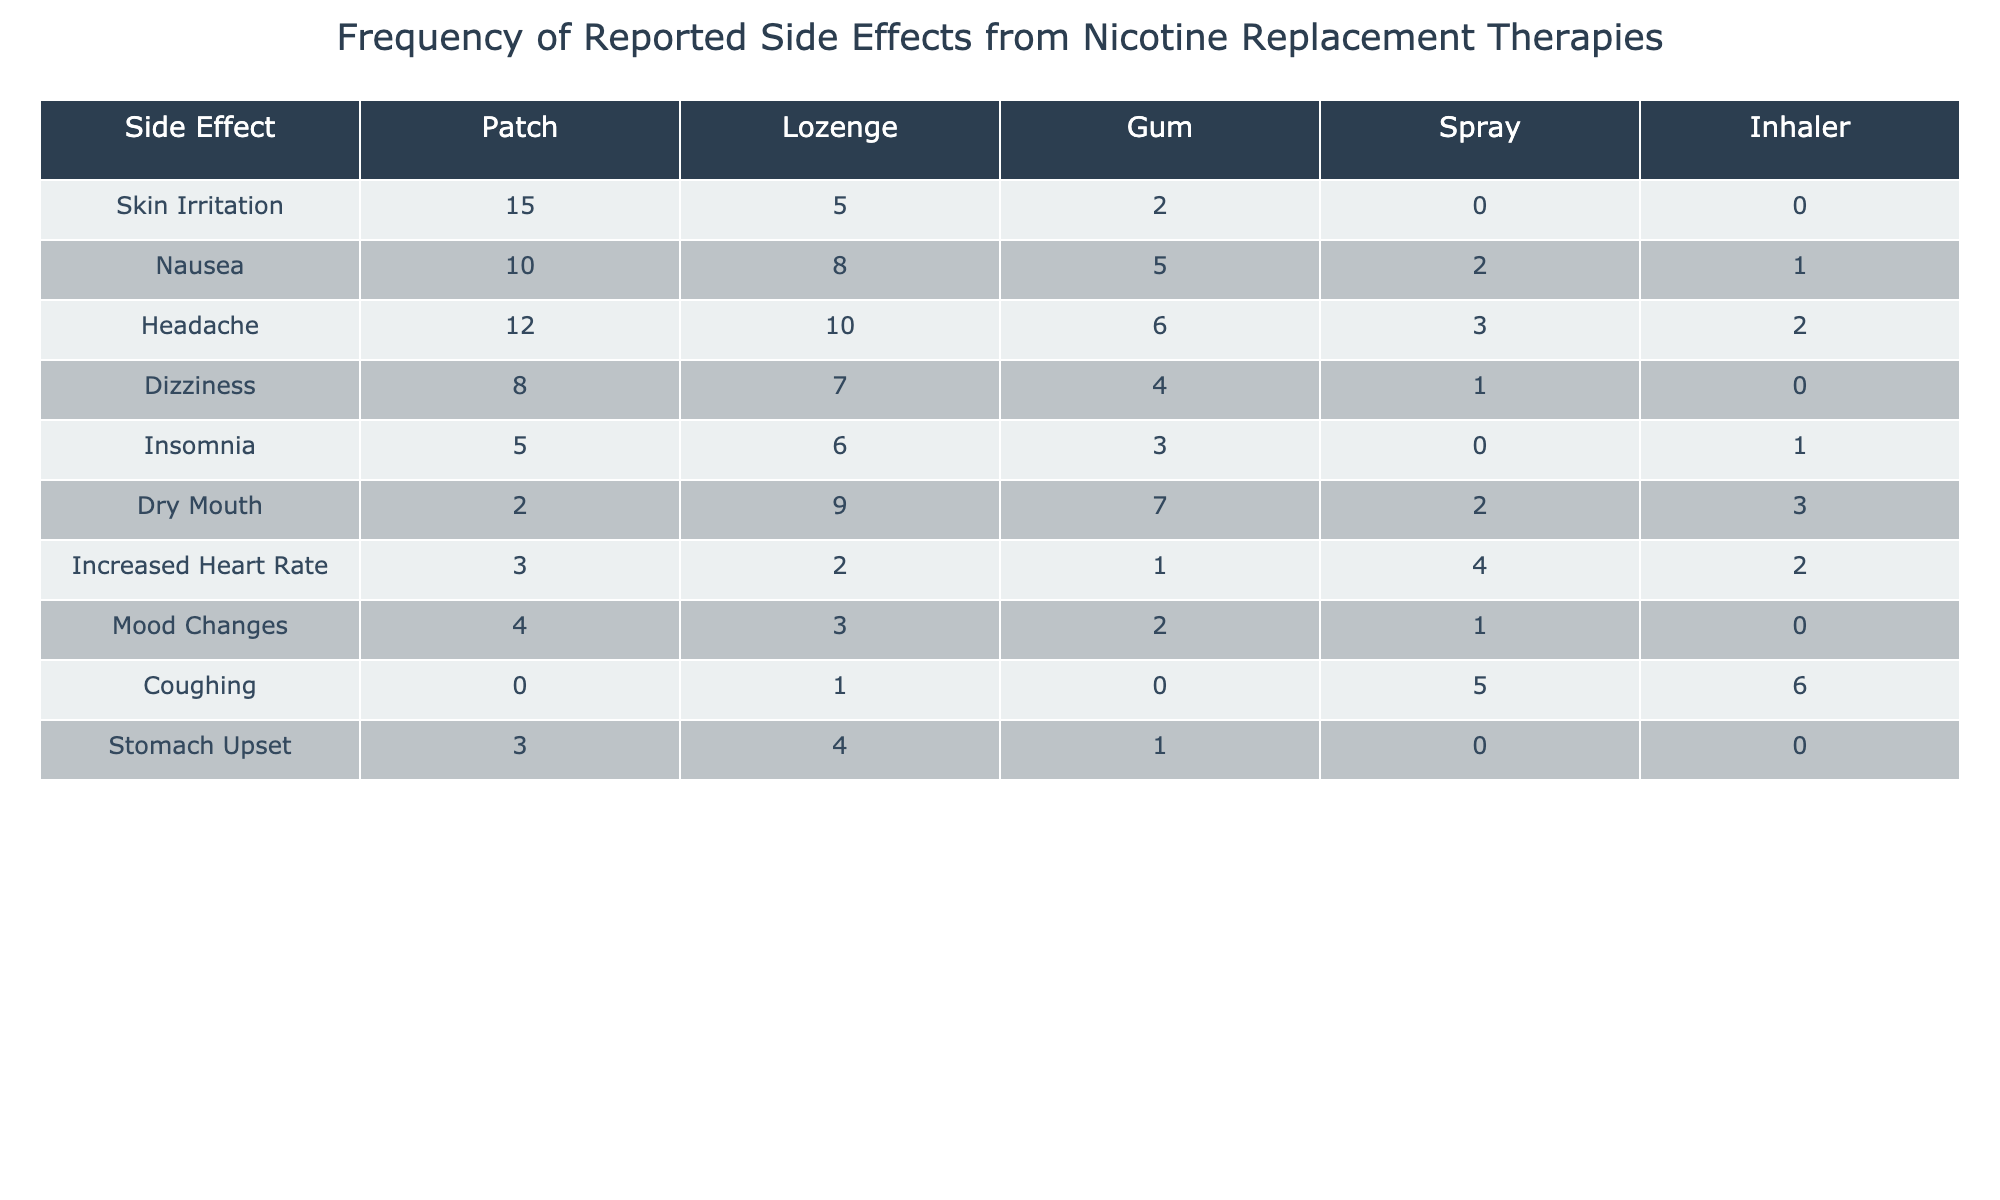What is the most frequently reported side effect across all nicotine replacement therapies? To determine the most frequent side effect, I will look at the total counts for each side effect by summing up the values across all therapy types. Summing them gives: Skin Irritation (22), Nausea (26), Headache (33), Dizziness (20), Insomnia (15), Dry Mouth (23), Increased Heart Rate (12), Mood Changes (10), Coughing (12), and Stomach Upset (8). The highest total is for Headache with 33.
Answer: Headache Which nicotine replacement therapy has the highest occurrence of Nausea as a side effect? Looking at the Nausea row, the occurrences are Patch (10), Lozenge (8), Gum (5), Spray (2), and Inhaler (1). The highest occurrence of Nausea is from Patch with 10 cases.
Answer: Patch What is the total number of reported side effects for Gum? To find the total for Gum, I will add up the occurrences for all side effects listed under the Gum column: 2 (Skin Irritation) + 5 (Nausea) + 6 (Headache) + 4 (Dizziness) + 3 (Insomnia) + 7 (Dry Mouth) + 1 (Increased Heart Rate) + 2 (Mood Changes) + 0 (Coughing) + 1 (Stomach Upset) = 31.
Answer: 31 Are there any reported cases of Coughing with the Patch treatment? Checking the Coughing row under the Patch column, it shows 0 occurrences. Therefore, there are no reported cases of Coughing from the Patch.
Answer: No What side effect has the lowest occurrence in the Spray therapy? In the Spray column, I will review the occurrences: Skin Irritation (0), Nausea (2), Headache (3), Dizziness (1), Insomnia (0), Dry Mouth (2), Increased Heart Rate (4), Mood Changes (1), Coughing (5), and Stomach Upset (0). The lowest occurrences are for Skin Irritation, Insomnia, and Stomach Upset, each at 0.
Answer: Skin Irritation, Insomnia, Stomach Upset What percentage of the reported side effects for Inhaler are due to Coughing? First, I sum the values for Inhaler: 0 (Skin Irritation) + 1 (Nausea) + 2 (Headache) + 0 (Dizziness) + 1 (Insomnia) + 3 (Dry Mouth) + 2 (Increased Heart Rate) + 0 (Mood Changes) + 6 (Coughing) + 0 (Stomach Upset) = 15. Now, I find the proportion of Coughing: 6 out of 15 total. The percentage for Coughing is (6/15)*100 = 40%.
Answer: 40% Which side effect is reported more frequently in the Patch compared to the Inhaler? By examining the table, I will look at each side effect for both the Patch and Inhaler. The counts for Patch include: Skin Irritation (15), Nausea (10), Headache (12), Dizziness (8), Insomnia (5), Dry Mouth (2), Increased Heart Rate (3), Mood Changes (4), Coughing (0), and Stomach Upset (3). For Inhaler: Skin Irritation (0), Nausea (1), Headache (2), Dizziness (0), Insomnia (1), Dry Mouth (3), Increased Heart Rate (2), Mood Changes (0), Coughing (6), and Stomach Upset (0). The side effects reported more in Patch than Inhaler are Skin Irritation, Nausea, Headache, Dizziness, Insomnia, Dry Mouth, Increased Heart Rate, and Mood Changes.
Answer: Skin Irritation, Nausea, Headache, Dizziness, Insomnia, Dry Mouth, Increased Heart Rate, Mood Changes 